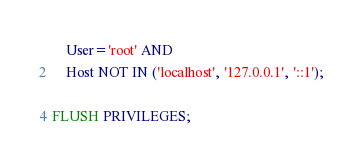<code> <loc_0><loc_0><loc_500><loc_500><_SQL_>    User='root' AND
    Host NOT IN ('localhost', '127.0.0.1', '::1');

FLUSH PRIVILEGES;
</code> 